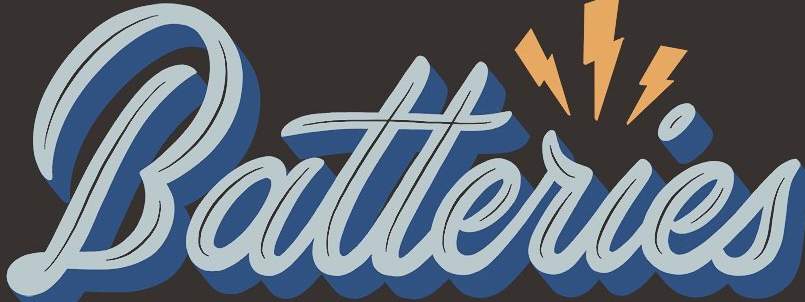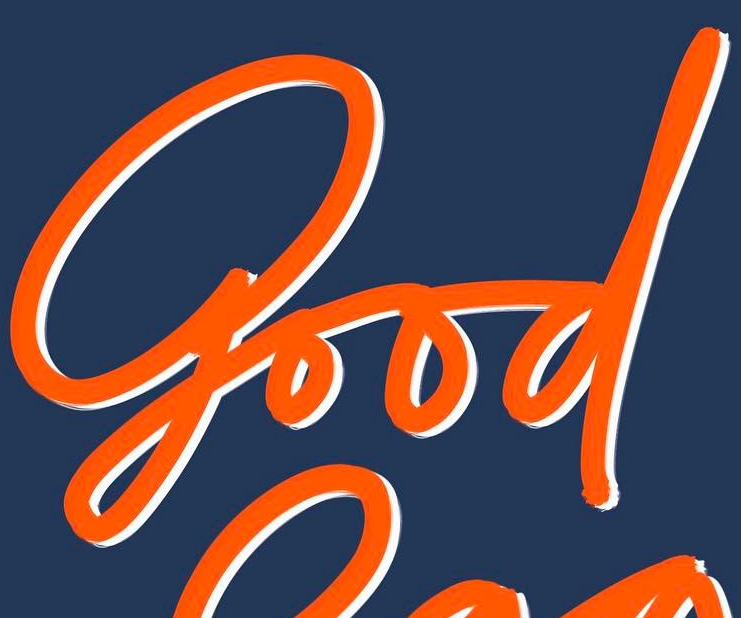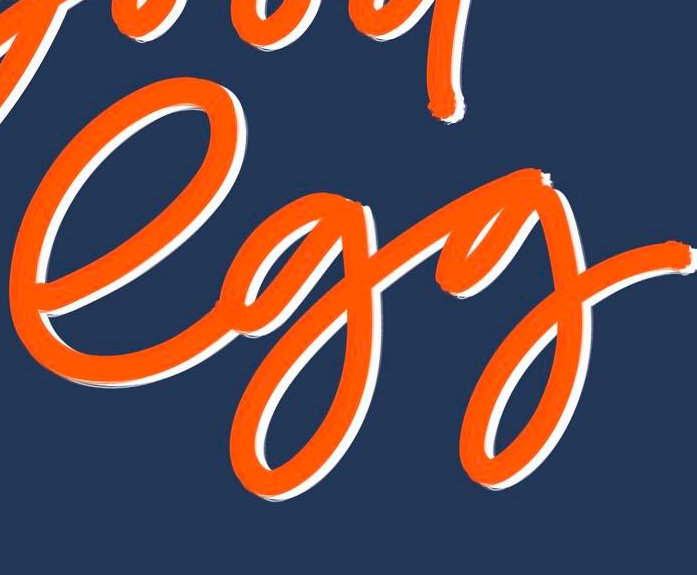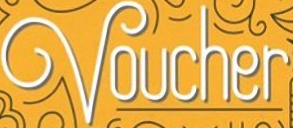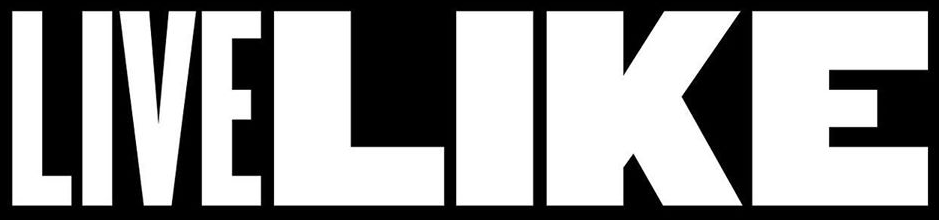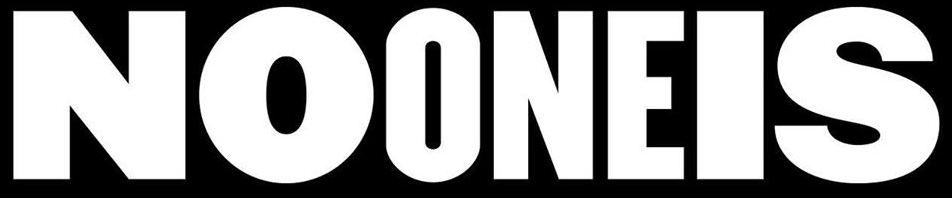Transcribe the words shown in these images in order, separated by a semicolon. Batteries; good; egg; Voucher; LIVELIKE; NOONEIS 